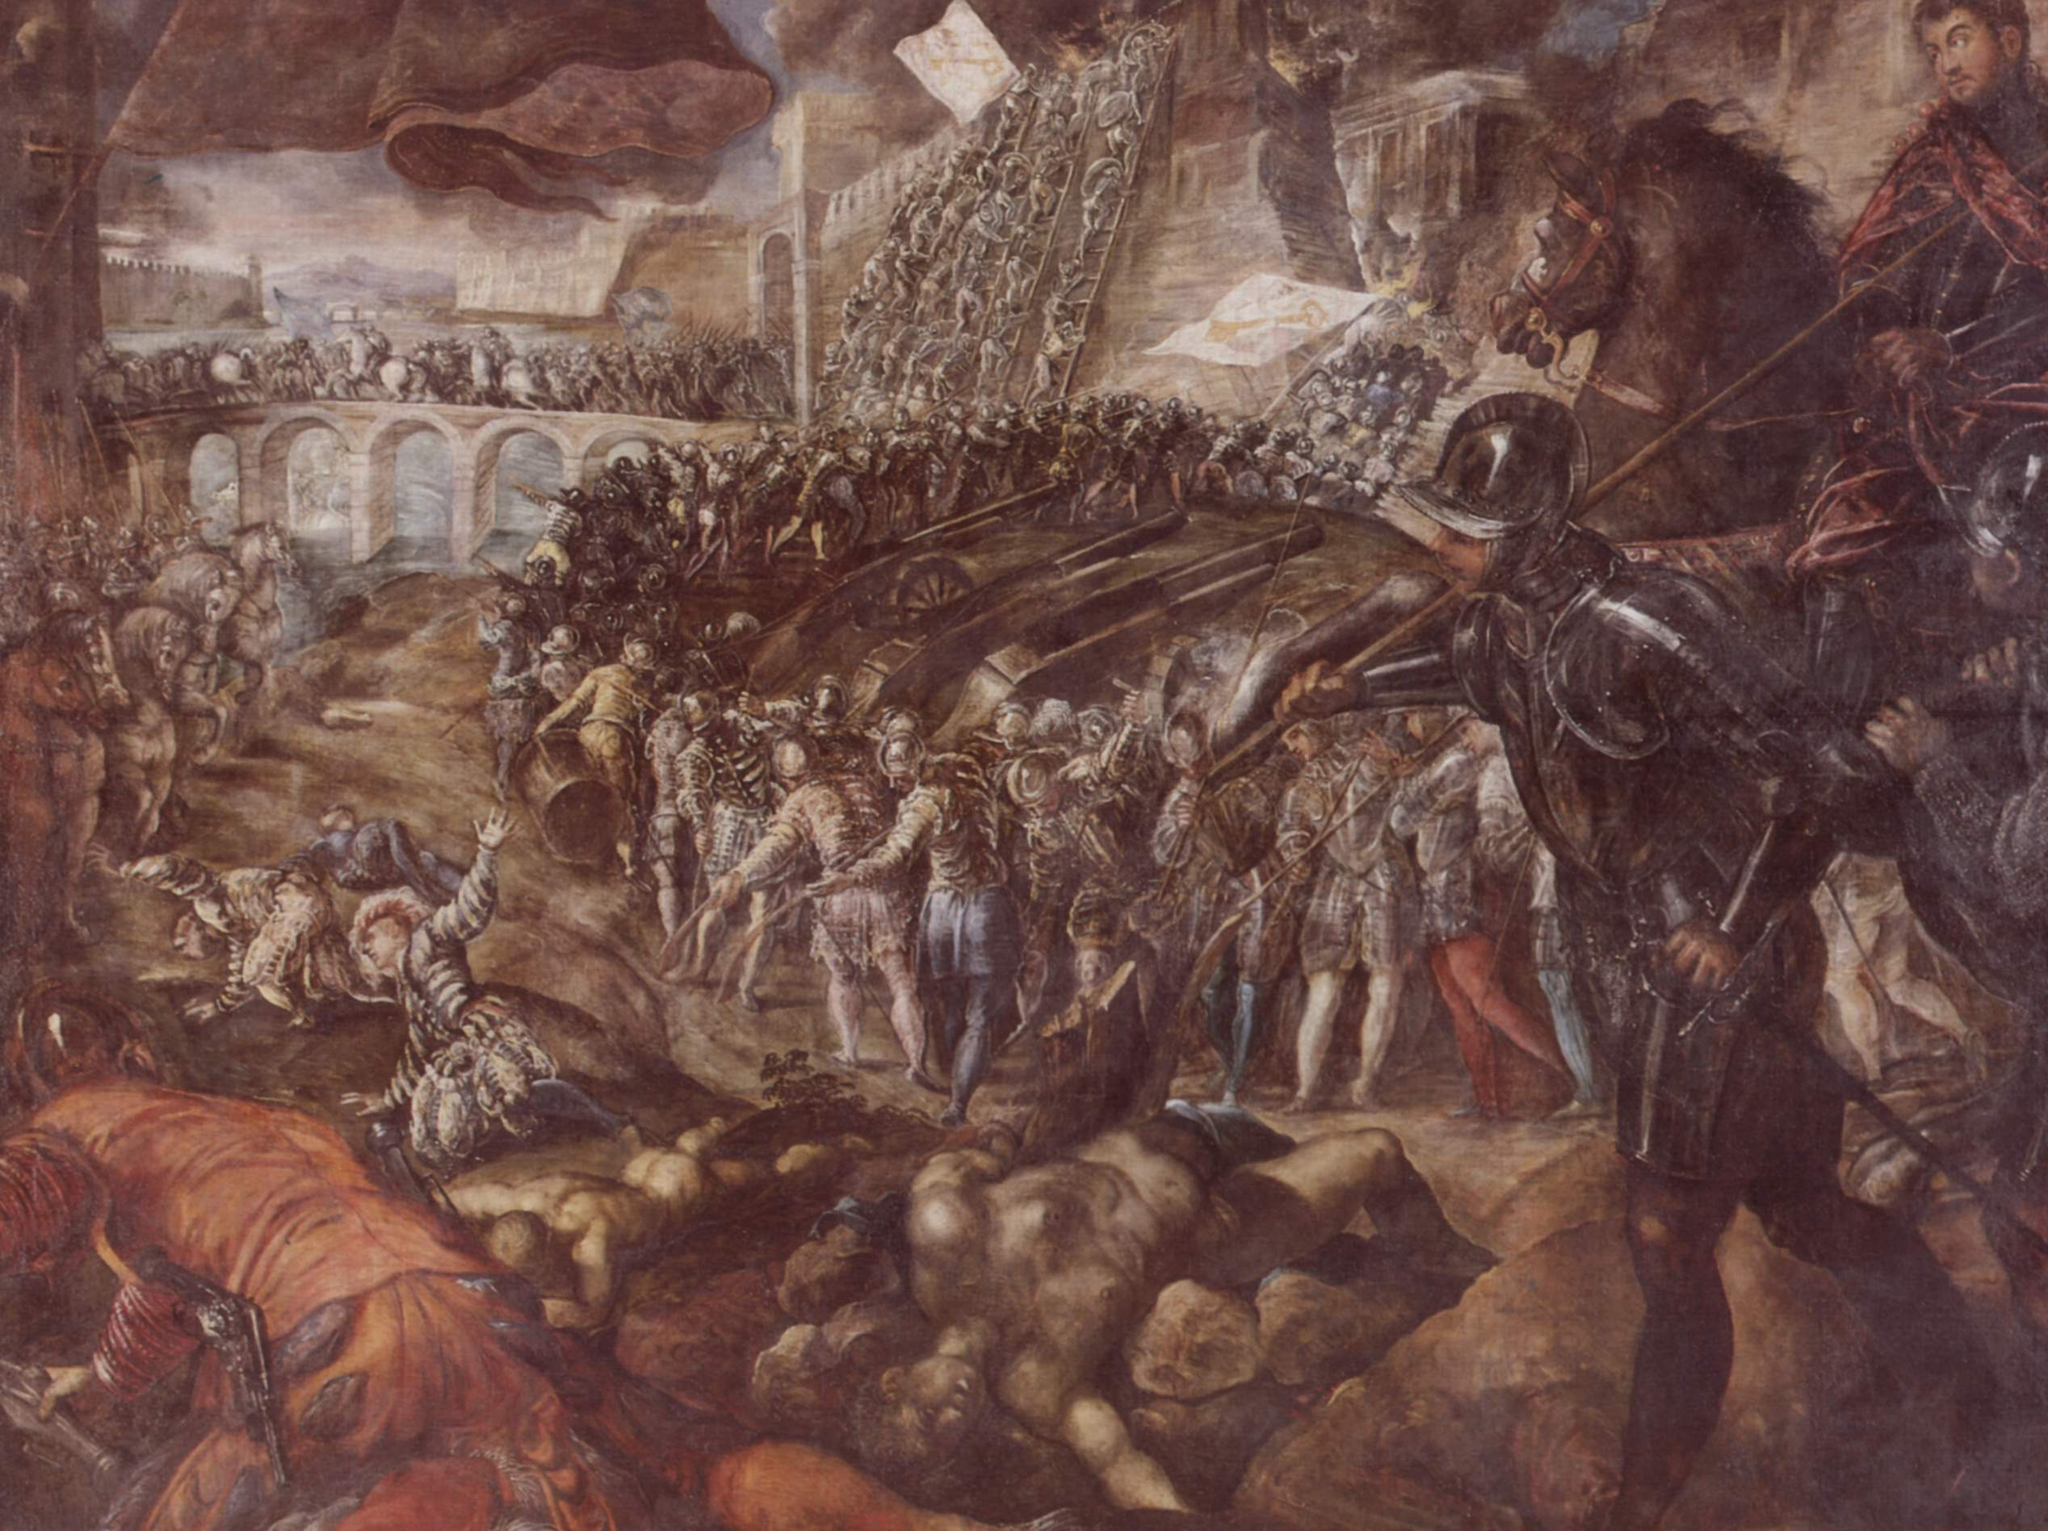Analyze the image in a comprehensive and detailed manner. The image portrays a dramatic and intense battle scene, evocative of art from the Renaissance period. The composition is dominated by a chaotic melee of soldiers and weapons, capturing the ferocity and confusion of war. The soldiers, clad in detailed armor, wield a variety of weapons, from swords to lances, as they clash in a fierce struggle. The presence of both human and animal figures, including mounted knights, adds to the dynamic and tumultuous nature of the scene.

Foregrounded figures and receding lines of combatants create a deep sense of space and movement. The earthy tones, predominantly browns and ochres, lend a grounded realism to the depiction, while the contrasting blue of the sky adds depth and separates the battle from the heavens.

The historical setting is emphasized by architectural elements such as fortifications and bridges, pointing to a significant military engagement, possibly a siege or a battle in a medieval or early modern period. The artist masterfully conveys the sheer scale and intensity of the conflict, with overlapping figures and dramatic gestures underscoring the brutality and desperation of the scene. Overall, the work stands as a vivid representation of historical warfare, rich in detail and emotional impact. 